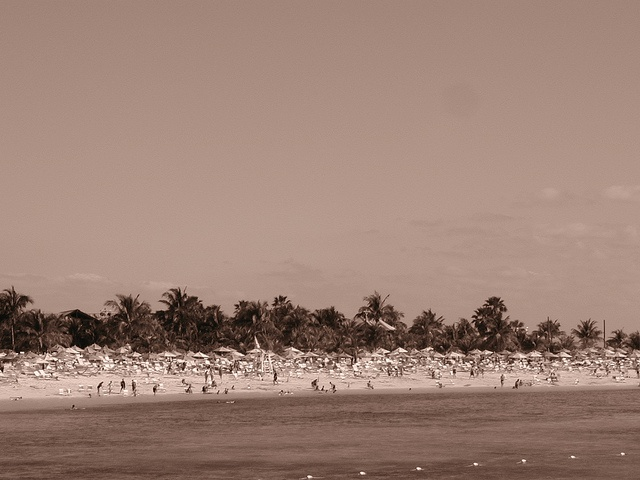Describe the objects in this image and their specific colors. I can see umbrella in gray, black, maroon, and darkgray tones, people in gray, tan, darkgray, and lightgray tones, umbrella in gray, darkgray, tan, and lightgray tones, people in gray, darkgray, and black tones, and umbrella in gray, lightgray, darkgray, maroon, and black tones in this image. 